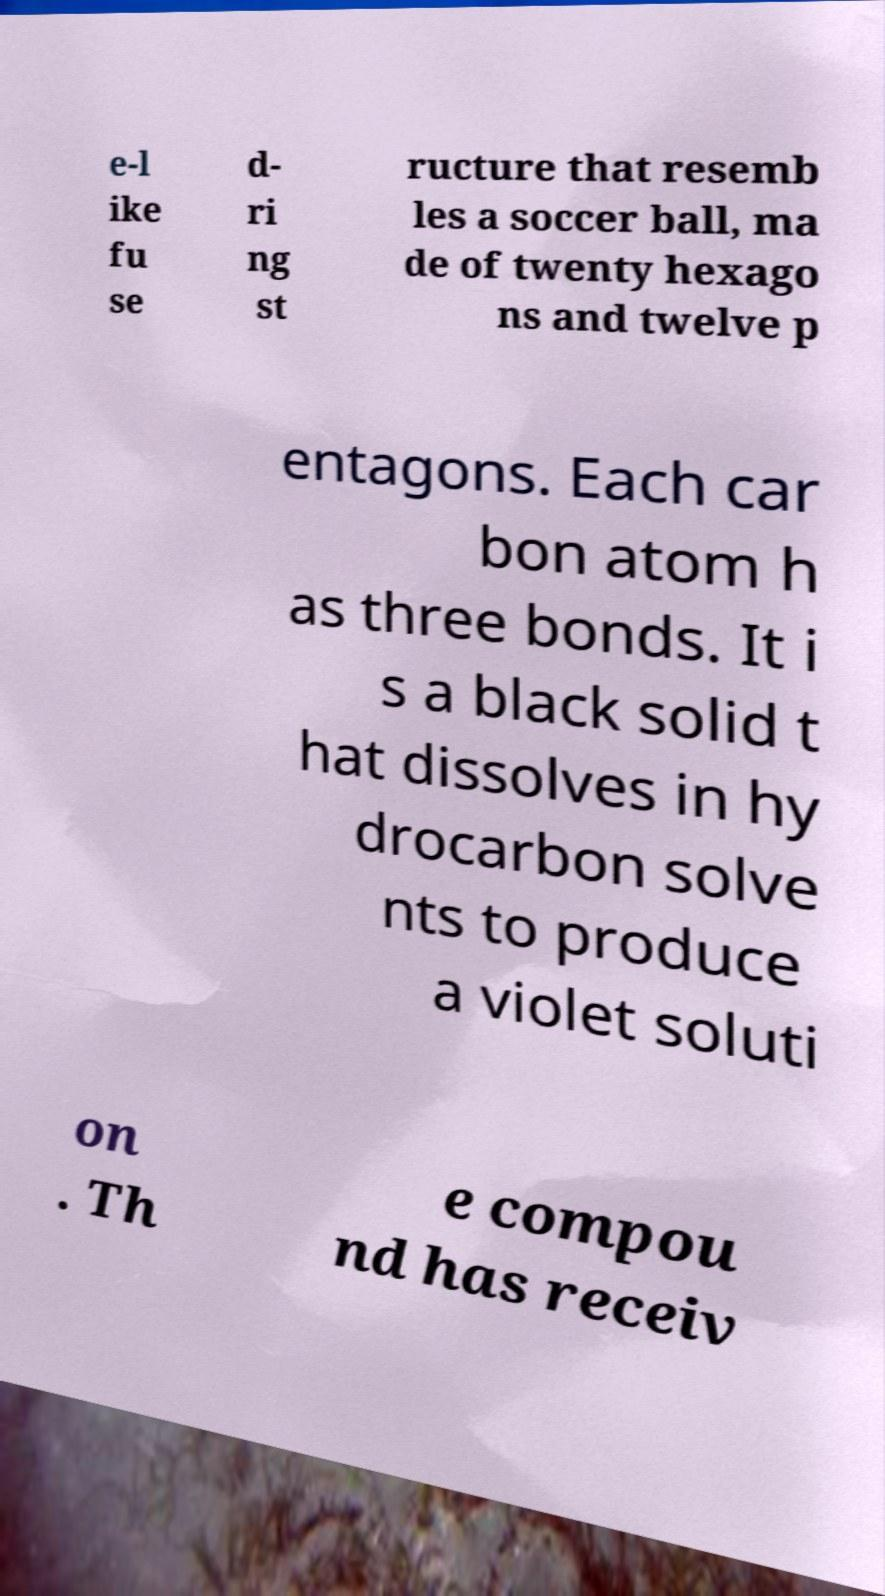What messages or text are displayed in this image? I need them in a readable, typed format. e-l ike fu se d- ri ng st ructure that resemb les a soccer ball, ma de of twenty hexago ns and twelve p entagons. Each car bon atom h as three bonds. It i s a black solid t hat dissolves in hy drocarbon solve nts to produce a violet soluti on . Th e compou nd has receiv 